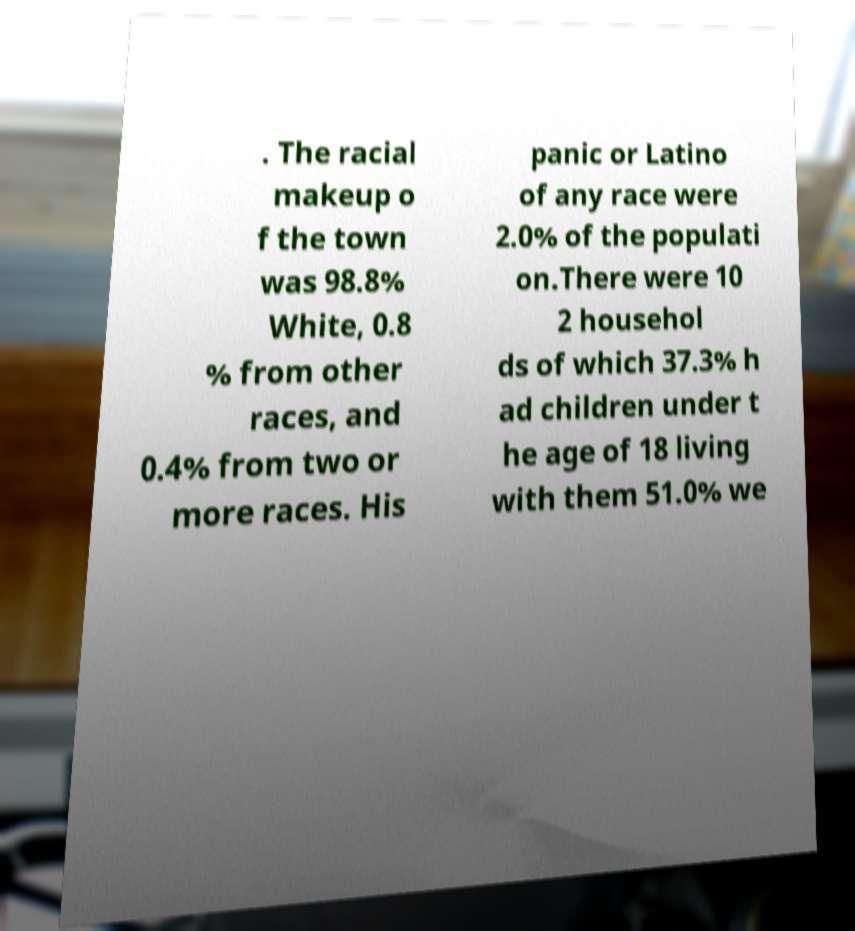What messages or text are displayed in this image? I need them in a readable, typed format. . The racial makeup o f the town was 98.8% White, 0.8 % from other races, and 0.4% from two or more races. His panic or Latino of any race were 2.0% of the populati on.There were 10 2 househol ds of which 37.3% h ad children under t he age of 18 living with them 51.0% we 